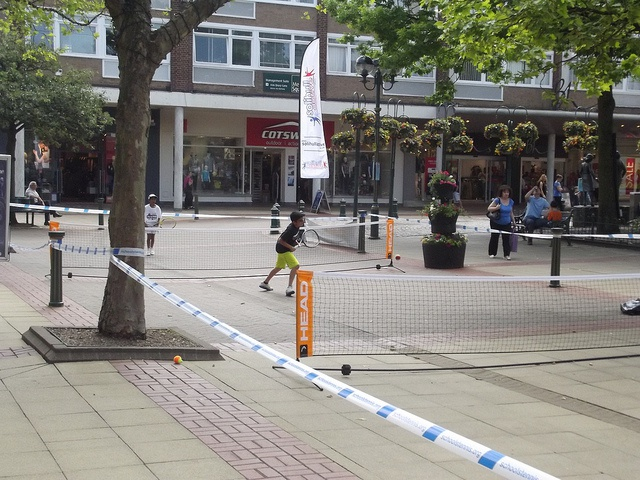Describe the objects in this image and their specific colors. I can see people in gray, black, darkgray, and lightgray tones, people in gray, black, navy, and blue tones, people in gray, black, and darkblue tones, people in gray, darkgray, and black tones, and people in gray, black, darkgray, and lightgray tones in this image. 